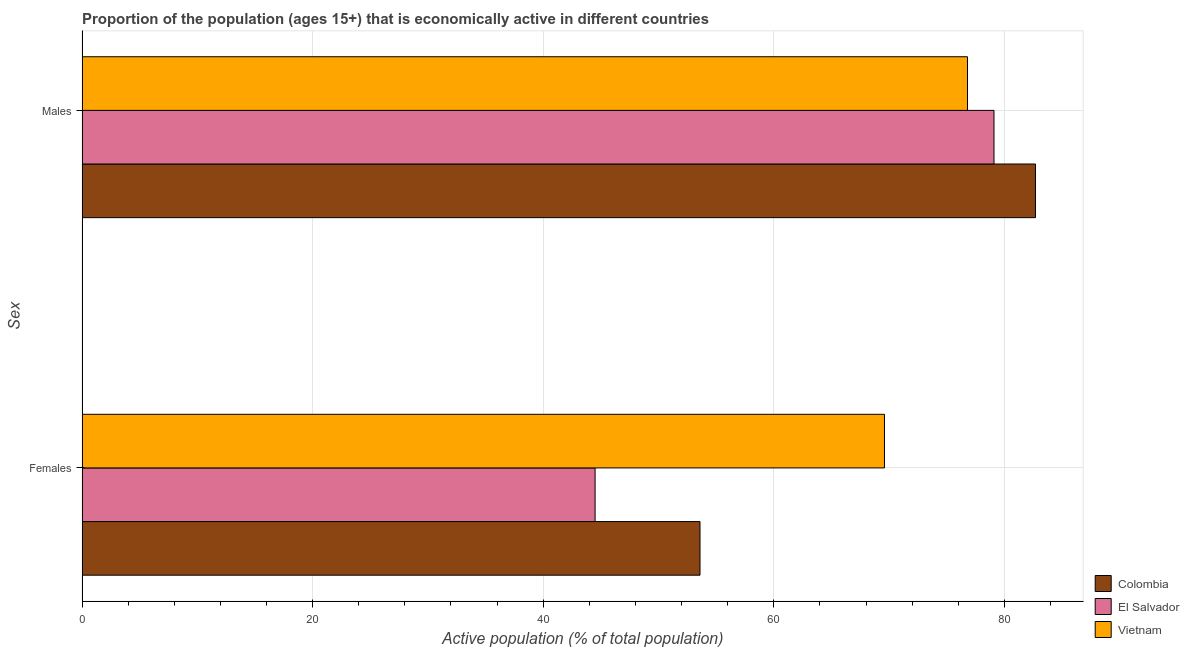How many groups of bars are there?
Your answer should be very brief. 2. Are the number of bars per tick equal to the number of legend labels?
Your answer should be very brief. Yes. Are the number of bars on each tick of the Y-axis equal?
Your response must be concise. Yes. How many bars are there on the 1st tick from the top?
Your answer should be compact. 3. How many bars are there on the 2nd tick from the bottom?
Give a very brief answer. 3. What is the label of the 2nd group of bars from the top?
Your response must be concise. Females. What is the percentage of economically active female population in Vietnam?
Ensure brevity in your answer.  69.6. Across all countries, what is the maximum percentage of economically active female population?
Offer a terse response. 69.6. Across all countries, what is the minimum percentage of economically active male population?
Offer a terse response. 76.8. In which country was the percentage of economically active male population maximum?
Offer a very short reply. Colombia. In which country was the percentage of economically active male population minimum?
Make the answer very short. Vietnam. What is the total percentage of economically active male population in the graph?
Make the answer very short. 238.6. What is the difference between the percentage of economically active male population in El Salvador and that in Colombia?
Provide a succinct answer. -3.6. What is the difference between the percentage of economically active male population in Colombia and the percentage of economically active female population in Vietnam?
Offer a terse response. 13.1. What is the average percentage of economically active male population per country?
Offer a terse response. 79.53. What is the difference between the percentage of economically active male population and percentage of economically active female population in Vietnam?
Offer a very short reply. 7.2. What is the ratio of the percentage of economically active male population in Vietnam to that in Colombia?
Provide a succinct answer. 0.93. In how many countries, is the percentage of economically active male population greater than the average percentage of economically active male population taken over all countries?
Ensure brevity in your answer.  1. What does the 2nd bar from the bottom in Females represents?
Provide a succinct answer. El Salvador. Are all the bars in the graph horizontal?
Provide a short and direct response. Yes. How many countries are there in the graph?
Provide a short and direct response. 3. Does the graph contain any zero values?
Give a very brief answer. No. Does the graph contain grids?
Provide a succinct answer. Yes. How many legend labels are there?
Your response must be concise. 3. What is the title of the graph?
Ensure brevity in your answer.  Proportion of the population (ages 15+) that is economically active in different countries. Does "Croatia" appear as one of the legend labels in the graph?
Your answer should be compact. No. What is the label or title of the X-axis?
Make the answer very short. Active population (% of total population). What is the label or title of the Y-axis?
Your response must be concise. Sex. What is the Active population (% of total population) of Colombia in Females?
Your answer should be very brief. 53.6. What is the Active population (% of total population) in El Salvador in Females?
Your answer should be very brief. 44.5. What is the Active population (% of total population) of Vietnam in Females?
Provide a succinct answer. 69.6. What is the Active population (% of total population) in Colombia in Males?
Your answer should be compact. 82.7. What is the Active population (% of total population) of El Salvador in Males?
Your answer should be compact. 79.1. What is the Active population (% of total population) in Vietnam in Males?
Give a very brief answer. 76.8. Across all Sex, what is the maximum Active population (% of total population) of Colombia?
Keep it short and to the point. 82.7. Across all Sex, what is the maximum Active population (% of total population) of El Salvador?
Keep it short and to the point. 79.1. Across all Sex, what is the maximum Active population (% of total population) of Vietnam?
Provide a short and direct response. 76.8. Across all Sex, what is the minimum Active population (% of total population) in Colombia?
Offer a very short reply. 53.6. Across all Sex, what is the minimum Active population (% of total population) of El Salvador?
Keep it short and to the point. 44.5. Across all Sex, what is the minimum Active population (% of total population) in Vietnam?
Your answer should be compact. 69.6. What is the total Active population (% of total population) of Colombia in the graph?
Keep it short and to the point. 136.3. What is the total Active population (% of total population) in El Salvador in the graph?
Give a very brief answer. 123.6. What is the total Active population (% of total population) in Vietnam in the graph?
Ensure brevity in your answer.  146.4. What is the difference between the Active population (% of total population) in Colombia in Females and that in Males?
Give a very brief answer. -29.1. What is the difference between the Active population (% of total population) of El Salvador in Females and that in Males?
Ensure brevity in your answer.  -34.6. What is the difference between the Active population (% of total population) of Vietnam in Females and that in Males?
Offer a terse response. -7.2. What is the difference between the Active population (% of total population) in Colombia in Females and the Active population (% of total population) in El Salvador in Males?
Offer a terse response. -25.5. What is the difference between the Active population (% of total population) of Colombia in Females and the Active population (% of total population) of Vietnam in Males?
Make the answer very short. -23.2. What is the difference between the Active population (% of total population) of El Salvador in Females and the Active population (% of total population) of Vietnam in Males?
Make the answer very short. -32.3. What is the average Active population (% of total population) of Colombia per Sex?
Your answer should be very brief. 68.15. What is the average Active population (% of total population) of El Salvador per Sex?
Make the answer very short. 61.8. What is the average Active population (% of total population) in Vietnam per Sex?
Keep it short and to the point. 73.2. What is the difference between the Active population (% of total population) of Colombia and Active population (% of total population) of El Salvador in Females?
Keep it short and to the point. 9.1. What is the difference between the Active population (% of total population) of El Salvador and Active population (% of total population) of Vietnam in Females?
Your response must be concise. -25.1. What is the difference between the Active population (% of total population) of Colombia and Active population (% of total population) of El Salvador in Males?
Make the answer very short. 3.6. What is the difference between the Active population (% of total population) in El Salvador and Active population (% of total population) in Vietnam in Males?
Provide a short and direct response. 2.3. What is the ratio of the Active population (% of total population) in Colombia in Females to that in Males?
Ensure brevity in your answer.  0.65. What is the ratio of the Active population (% of total population) of El Salvador in Females to that in Males?
Offer a very short reply. 0.56. What is the ratio of the Active population (% of total population) in Vietnam in Females to that in Males?
Offer a terse response. 0.91. What is the difference between the highest and the second highest Active population (% of total population) of Colombia?
Your response must be concise. 29.1. What is the difference between the highest and the second highest Active population (% of total population) of El Salvador?
Your response must be concise. 34.6. What is the difference between the highest and the lowest Active population (% of total population) in Colombia?
Your answer should be compact. 29.1. What is the difference between the highest and the lowest Active population (% of total population) of El Salvador?
Keep it short and to the point. 34.6. What is the difference between the highest and the lowest Active population (% of total population) in Vietnam?
Give a very brief answer. 7.2. 